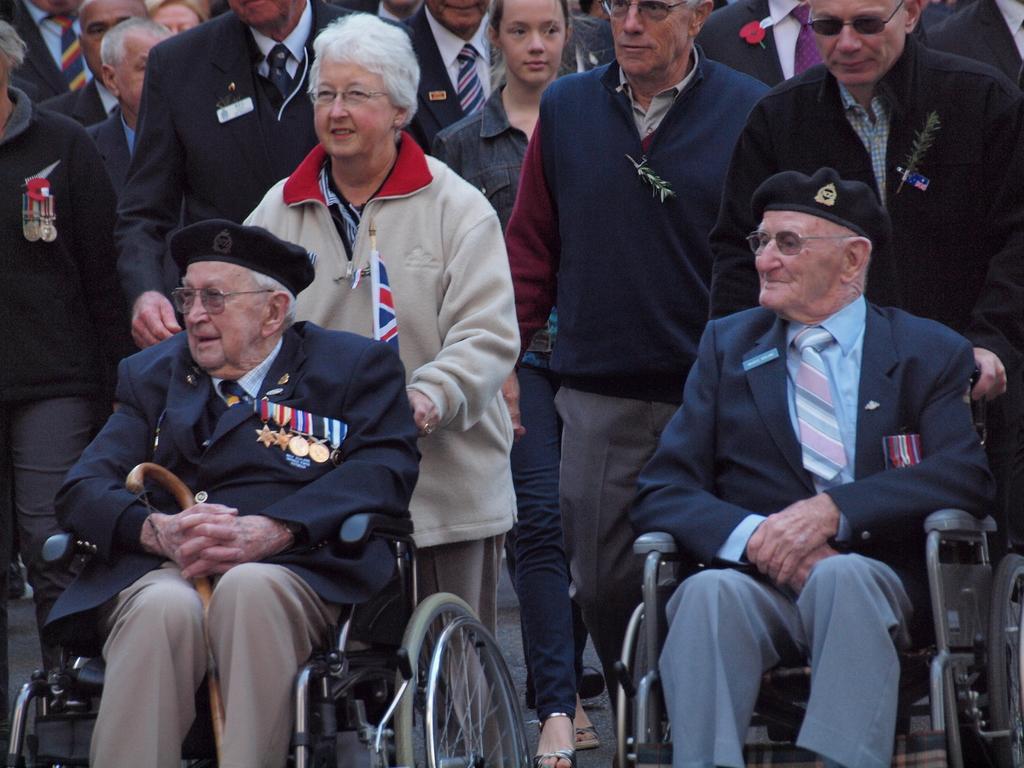Please provide a concise description of this image. In this image, I can see two old men sitting in the wheelchairs. I can see a group of people standing. This looks like a flag. 